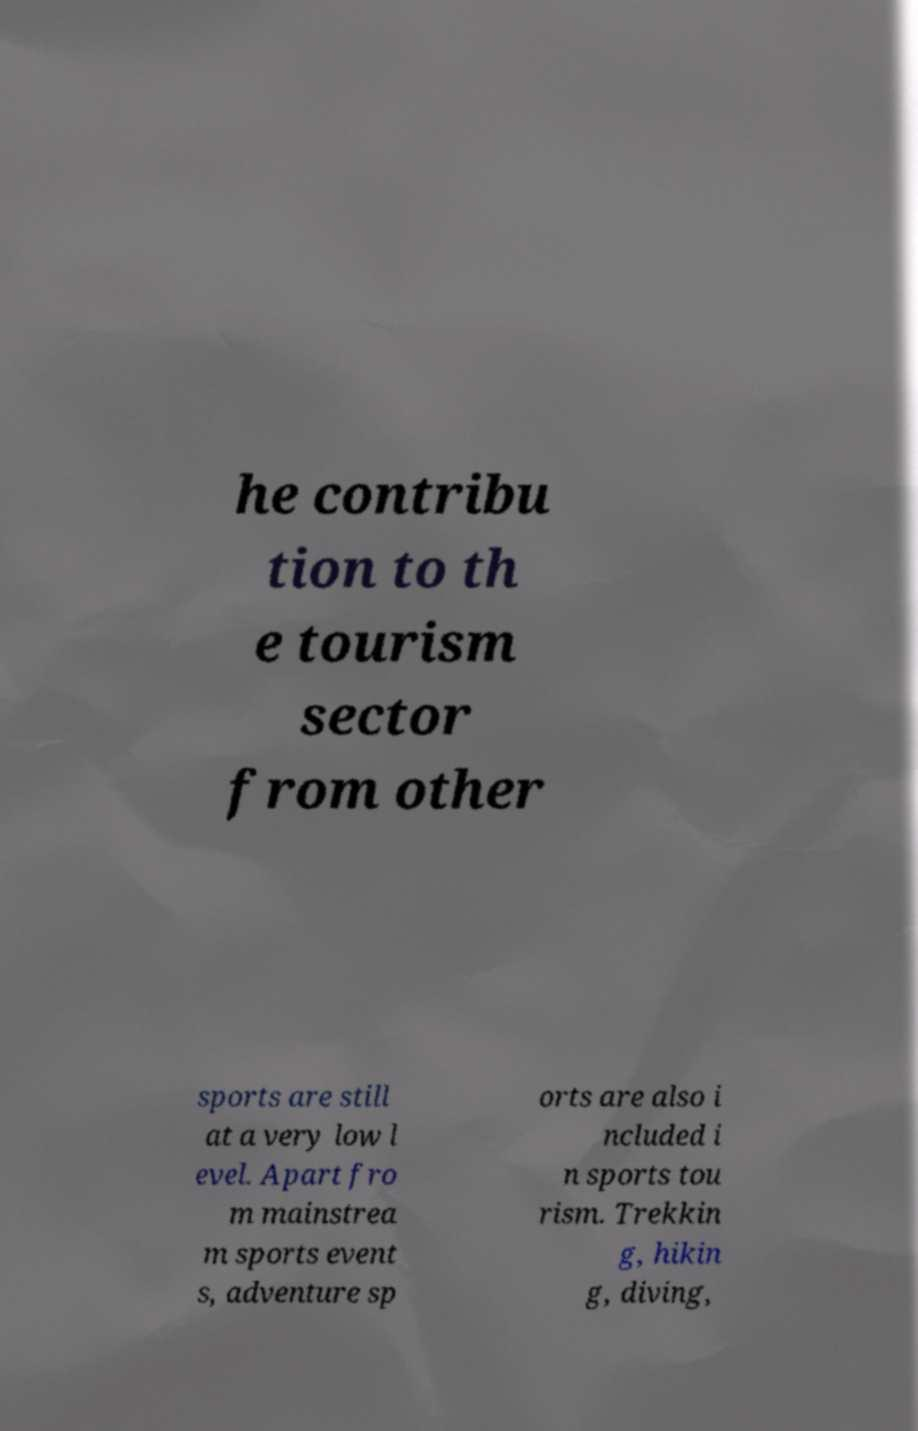There's text embedded in this image that I need extracted. Can you transcribe it verbatim? he contribu tion to th e tourism sector from other sports are still at a very low l evel. Apart fro m mainstrea m sports event s, adventure sp orts are also i ncluded i n sports tou rism. Trekkin g, hikin g, diving, 